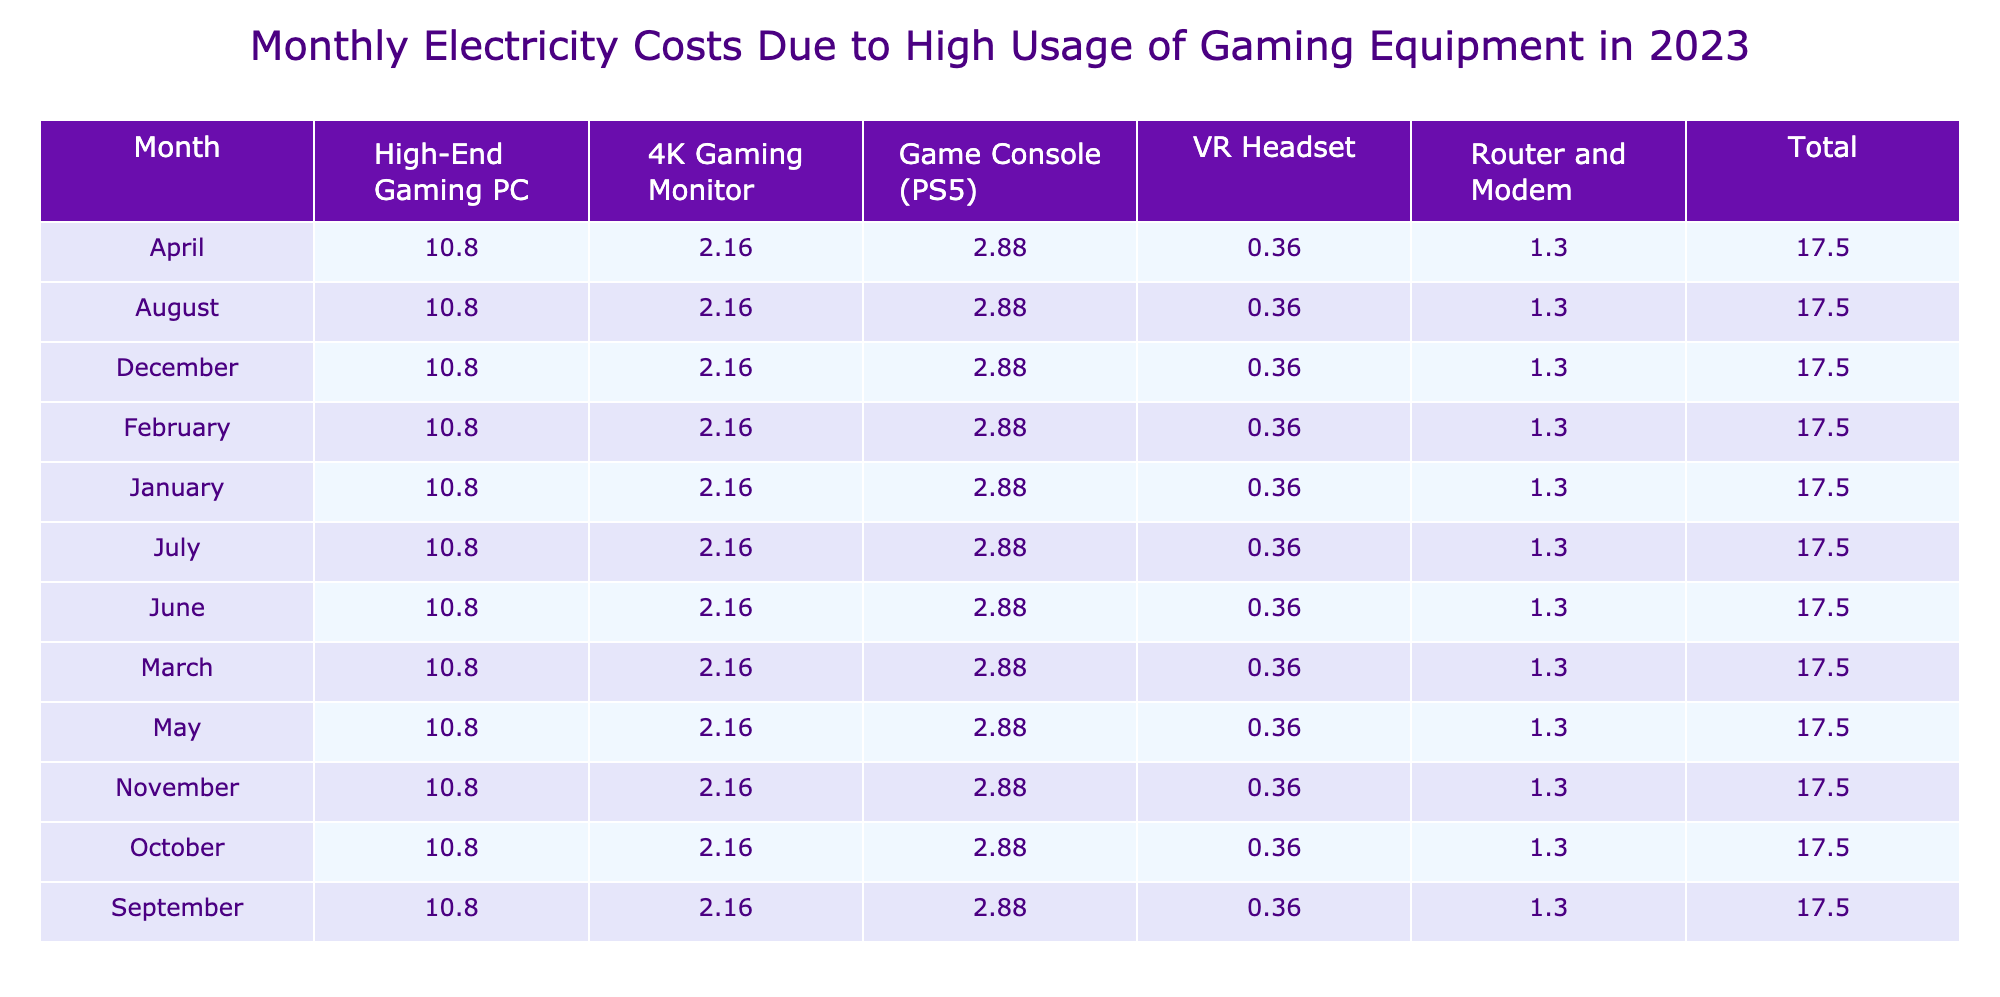What is the total electricity cost for January? In January, the electricity costs for each device are as follows: High-End Gaming PC: 10.80, 4K Gaming Monitor: 2.16, Router and Modem: 1.30, Game Console (PS5): 2.88, VR Headset: 0.36. Adding these together: 10.80 + 2.16 + 1.30 + 2.88 + 0.36 = 17.50.
Answer: 17.50 Which device had the highest electricity cost in December? In December, the costs for each device are: High-End Gaming PC: 10.80, 4K Gaming Monitor: 2.16, Router and Modem: 1.30, Game Console (PS5): 2.88, VR Headset: 0.36. The highest cost among these is 10.80 for the High-End Gaming PC.
Answer: High-End Gaming PC What is the average monthly electricity cost across all devices? Each month's total cost can be summed, resulting in 12 months at 17.50 each month (as calculated in the first question). Therefore, the average monthly cost is 17.50, since all months are identical.
Answer: 17.50 Did the Game Console (PS5) have a higher monthly cost than the Router and Modem in June? In June, the Game Console (PS5) cost 2.88, and the Router and Modem cost 1.30. Since 2.88 is greater than 1.30, the Game Console did have a higher cost.
Answer: Yes How much more did the High-End Gaming PC cost compared to the 4K Gaming Monitor in October? In October, the High-End Gaming PC cost 10.80 while the 4K Gaming Monitor cost 2.16. The difference in costs is 10.80 - 2.16 = 8.64.
Answer: 8.64 What is the total cost for all devices across the year? Summing the total electricity costs for each month gives 12 months x 17.50 = 210 for the entire year. Each month has been consistently at that total.
Answer: 210 Was the total electricity cost in August the same as in September? In August and September, the total electricity costs were both calculated to be 17.50. Therefore, both months had the same total cost.
Answer: Yes What is the percentage of total monthly cost attributed to the VR Headset in February? In February, the total monthly cost is 17.50. The VR Headset cost 0.36. To find the percentage, calculate (0.36 / 17.50) * 100 = 2.06%.
Answer: 2.06% 